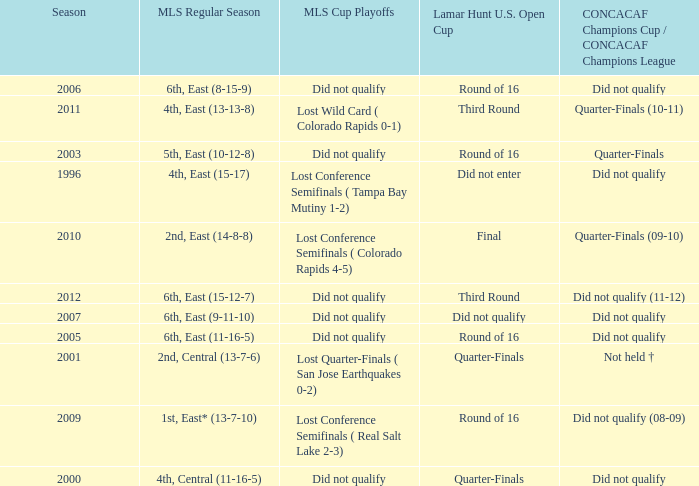How many mls cup playoffs where there for the mls regular season is 1st, east* (13-7-10)? 1.0. 